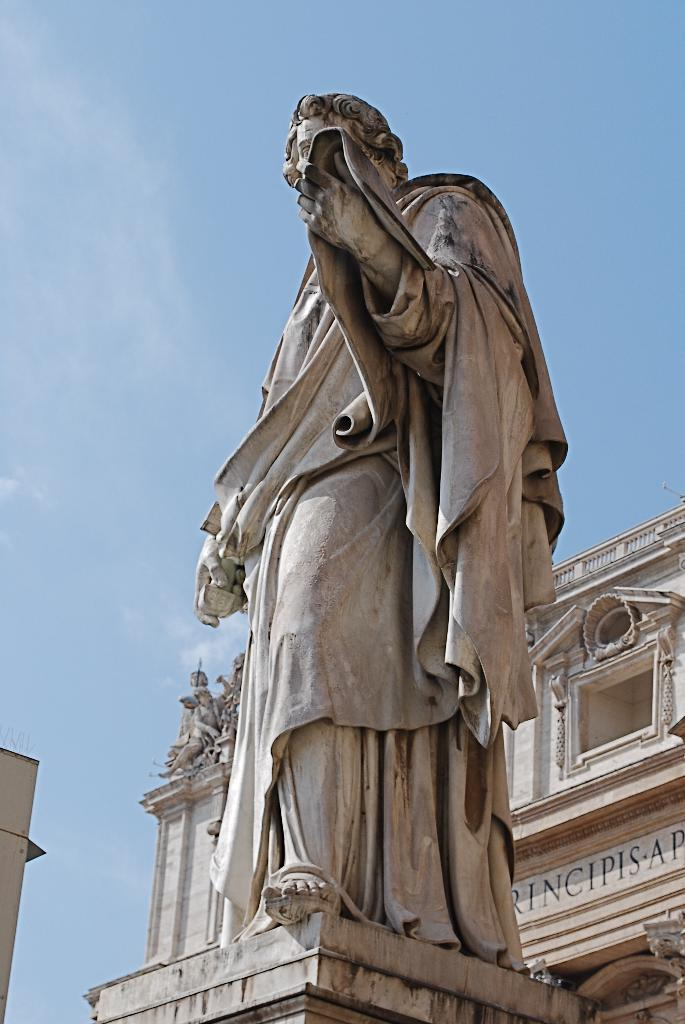What is the main subject in the center of the image? There is a statue in the center of the image. What can be seen in the background of the image? There is a building in the background of the image. What type of food is being prepared in the image? There is no food preparation visible in the image; it features a statue and a building in the background. 